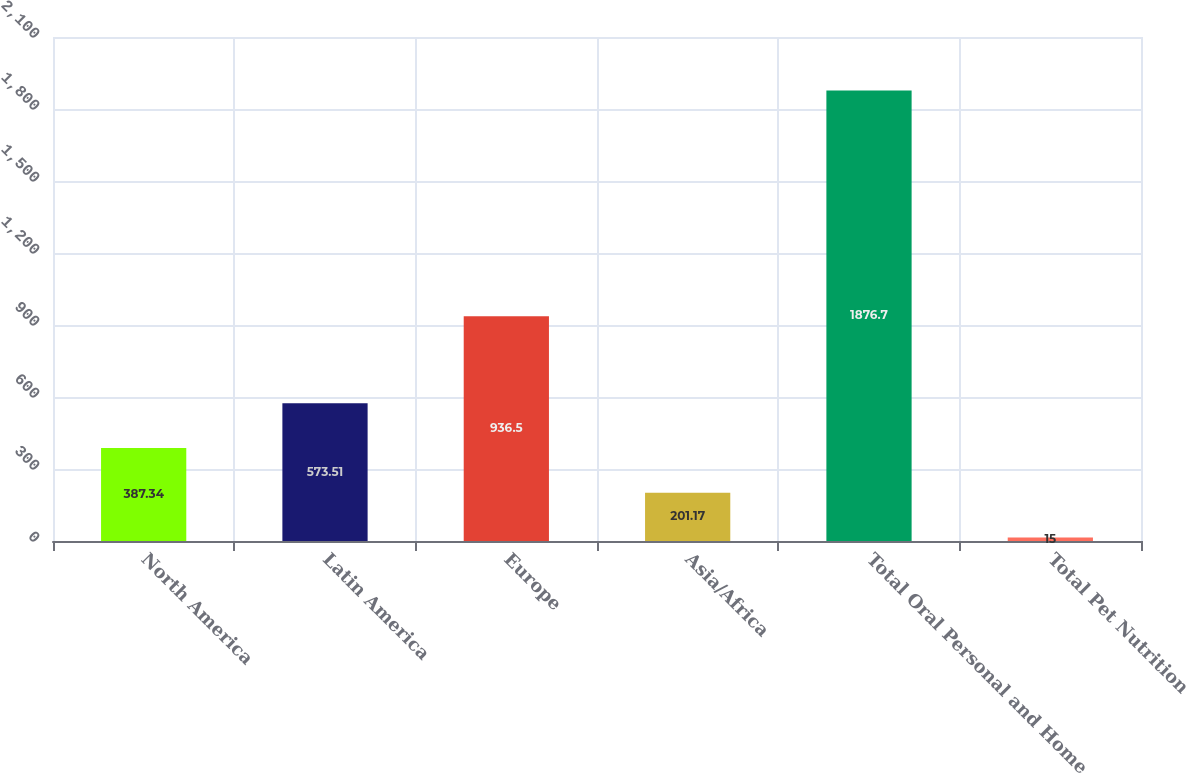<chart> <loc_0><loc_0><loc_500><loc_500><bar_chart><fcel>North America<fcel>Latin America<fcel>Europe<fcel>Asia/Africa<fcel>Total Oral Personal and Home<fcel>Total Pet Nutrition<nl><fcel>387.34<fcel>573.51<fcel>936.5<fcel>201.17<fcel>1876.7<fcel>15<nl></chart> 